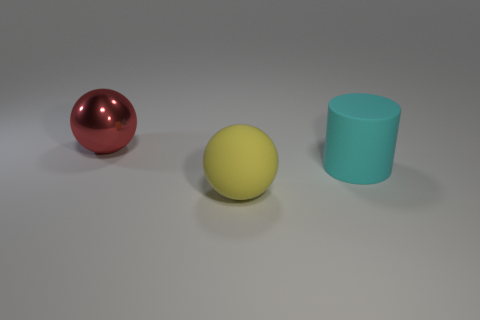Is there a brown cube?
Make the answer very short. No. What shape is the cyan thing that is the same material as the yellow ball?
Your answer should be very brief. Cylinder. Do the large red object and the large matte object to the right of the big yellow matte ball have the same shape?
Provide a succinct answer. No. There is a large ball in front of the big matte thing that is on the right side of the large matte ball; what is it made of?
Give a very brief answer. Rubber. What number of other objects are there of the same shape as the big cyan rubber object?
Ensure brevity in your answer.  0. There is a large thing in front of the large cyan cylinder; does it have the same shape as the thing behind the rubber cylinder?
Provide a short and direct response. Yes. Is there anything else that has the same material as the large red thing?
Your answer should be compact. No. What is the cyan thing made of?
Make the answer very short. Rubber. What material is the ball in front of the large rubber cylinder?
Your answer should be compact. Rubber. Is there any other thing that has the same color as the metallic thing?
Provide a short and direct response. No. 